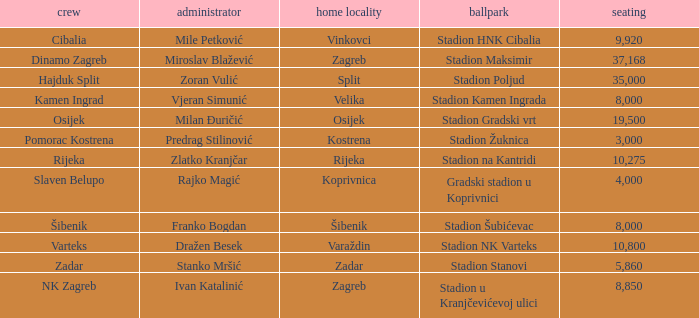What team has a home city of Koprivnica? Slaven Belupo. 